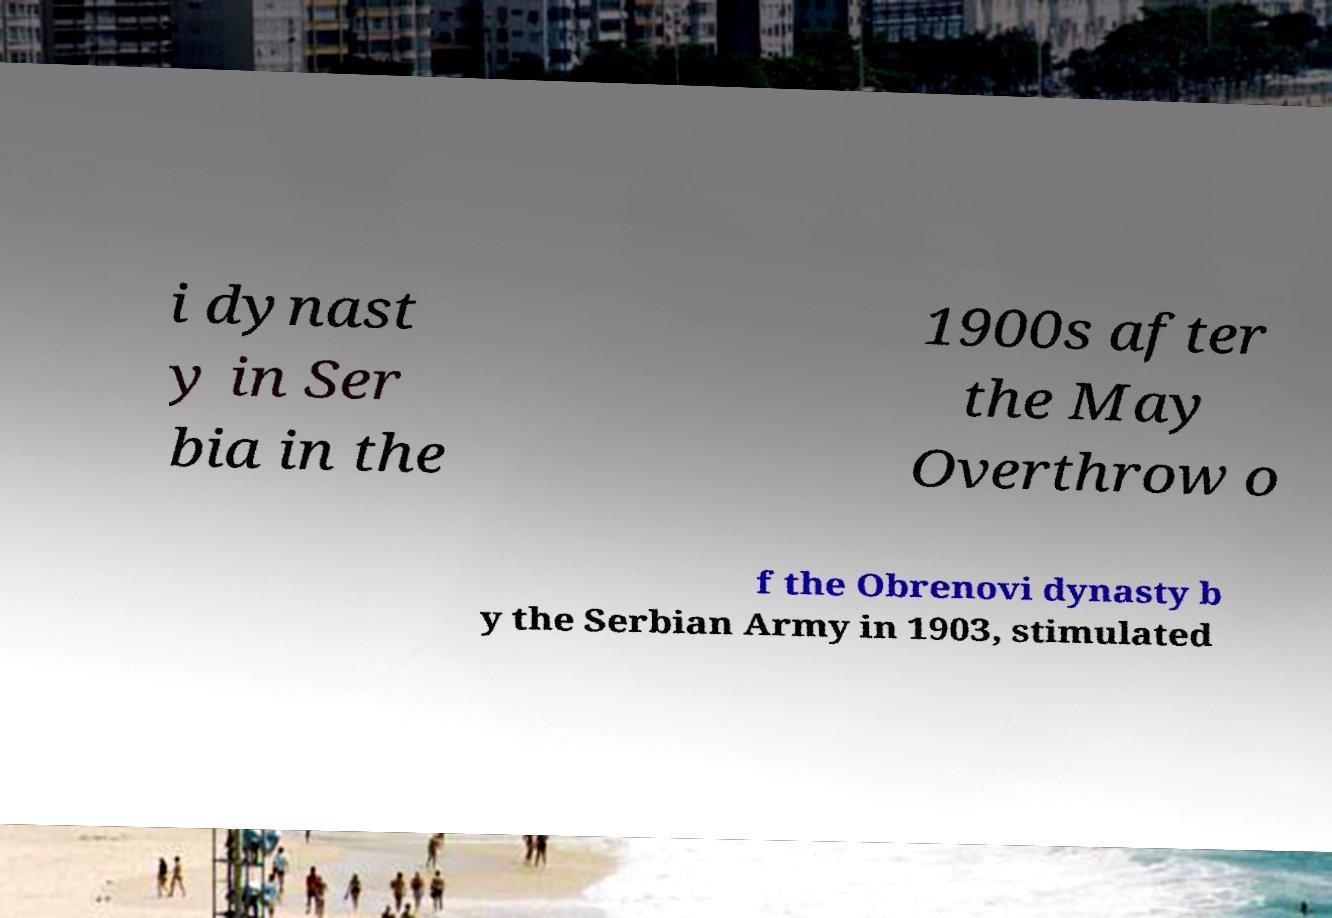Please identify and transcribe the text found in this image. i dynast y in Ser bia in the 1900s after the May Overthrow o f the Obrenovi dynasty b y the Serbian Army in 1903, stimulated 